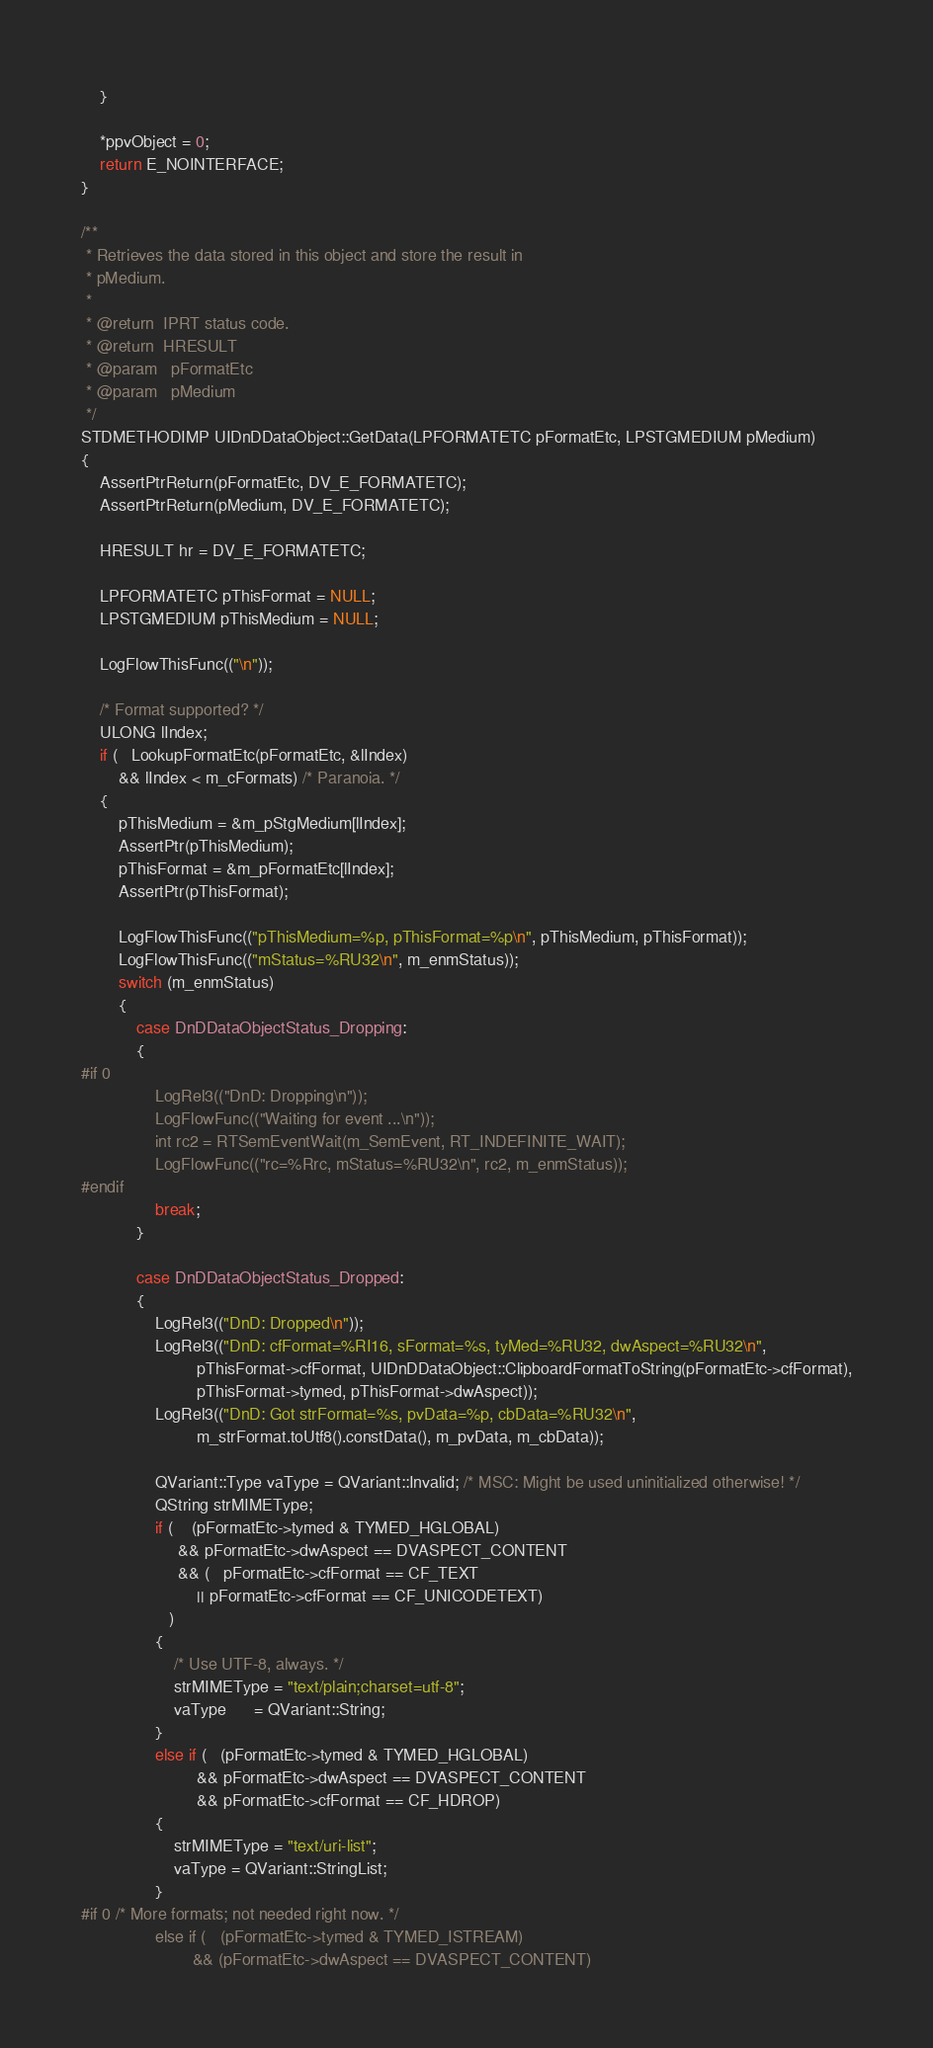<code> <loc_0><loc_0><loc_500><loc_500><_C++_>    }

    *ppvObject = 0;
    return E_NOINTERFACE;
}

/**
 * Retrieves the data stored in this object and store the result in
 * pMedium.
 *
 * @return  IPRT status code.
 * @return  HRESULT
 * @param   pFormatEtc
 * @param   pMedium
 */
STDMETHODIMP UIDnDDataObject::GetData(LPFORMATETC pFormatEtc, LPSTGMEDIUM pMedium)
{
    AssertPtrReturn(pFormatEtc, DV_E_FORMATETC);
    AssertPtrReturn(pMedium, DV_E_FORMATETC);

    HRESULT hr = DV_E_FORMATETC;

    LPFORMATETC pThisFormat = NULL;
    LPSTGMEDIUM pThisMedium = NULL;

    LogFlowThisFunc(("\n"));

    /* Format supported? */
    ULONG lIndex;
    if (   LookupFormatEtc(pFormatEtc, &lIndex)
        && lIndex < m_cFormats) /* Paranoia. */
    {
        pThisMedium = &m_pStgMedium[lIndex];
        AssertPtr(pThisMedium);
        pThisFormat = &m_pFormatEtc[lIndex];
        AssertPtr(pThisFormat);

        LogFlowThisFunc(("pThisMedium=%p, pThisFormat=%p\n", pThisMedium, pThisFormat));
        LogFlowThisFunc(("mStatus=%RU32\n", m_enmStatus));
        switch (m_enmStatus)
        {
            case DnDDataObjectStatus_Dropping:
            {
#if 0
                LogRel3(("DnD: Dropping\n"));
                LogFlowFunc(("Waiting for event ...\n"));
                int rc2 = RTSemEventWait(m_SemEvent, RT_INDEFINITE_WAIT);
                LogFlowFunc(("rc=%Rrc, mStatus=%RU32\n", rc2, m_enmStatus));
#endif
                break;
            }

            case DnDDataObjectStatus_Dropped:
            {
                LogRel3(("DnD: Dropped\n"));
                LogRel3(("DnD: cfFormat=%RI16, sFormat=%s, tyMed=%RU32, dwAspect=%RU32\n",
                         pThisFormat->cfFormat, UIDnDDataObject::ClipboardFormatToString(pFormatEtc->cfFormat),
                         pThisFormat->tymed, pThisFormat->dwAspect));
                LogRel3(("DnD: Got strFormat=%s, pvData=%p, cbData=%RU32\n",
                         m_strFormat.toUtf8().constData(), m_pvData, m_cbData));

                QVariant::Type vaType = QVariant::Invalid; /* MSC: Might be used uninitialized otherwise! */
                QString strMIMEType;
                if (    (pFormatEtc->tymed & TYMED_HGLOBAL)
                     && pFormatEtc->dwAspect == DVASPECT_CONTENT
                     && (   pFormatEtc->cfFormat == CF_TEXT
                         || pFormatEtc->cfFormat == CF_UNICODETEXT)
                   )
                {
                    /* Use UTF-8, always. */
                    strMIMEType = "text/plain;charset=utf-8";
                    vaType      = QVariant::String;
                }
                else if (   (pFormatEtc->tymed & TYMED_HGLOBAL)
                         && pFormatEtc->dwAspect == DVASPECT_CONTENT
                         && pFormatEtc->cfFormat == CF_HDROP)
                {
                    strMIMEType = "text/uri-list";
                    vaType = QVariant::StringList;
                }
#if 0 /* More formats; not needed right now. */
                else if (   (pFormatEtc->tymed & TYMED_ISTREAM)
                        && (pFormatEtc->dwAspect == DVASPECT_CONTENT)</code> 